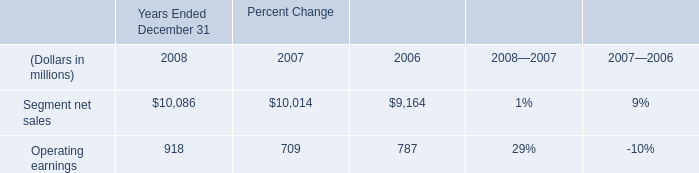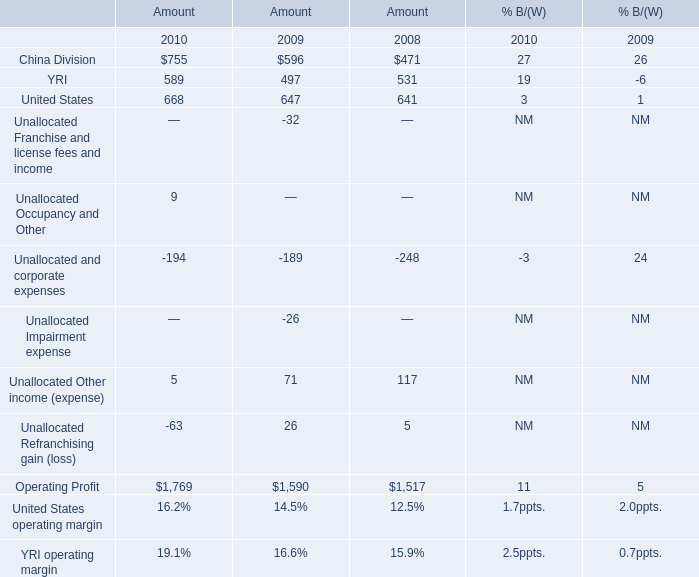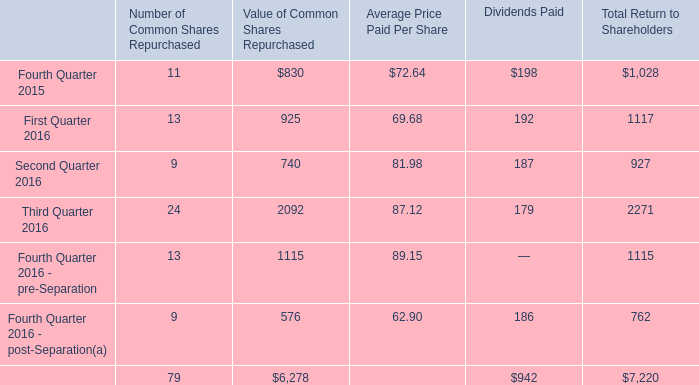What's the sum of Operating Profit of Amount 2008, and Segment net sales of Percent Change 2007 ? 
Computations: (1517.0 + 10014.0)
Answer: 11531.0. 